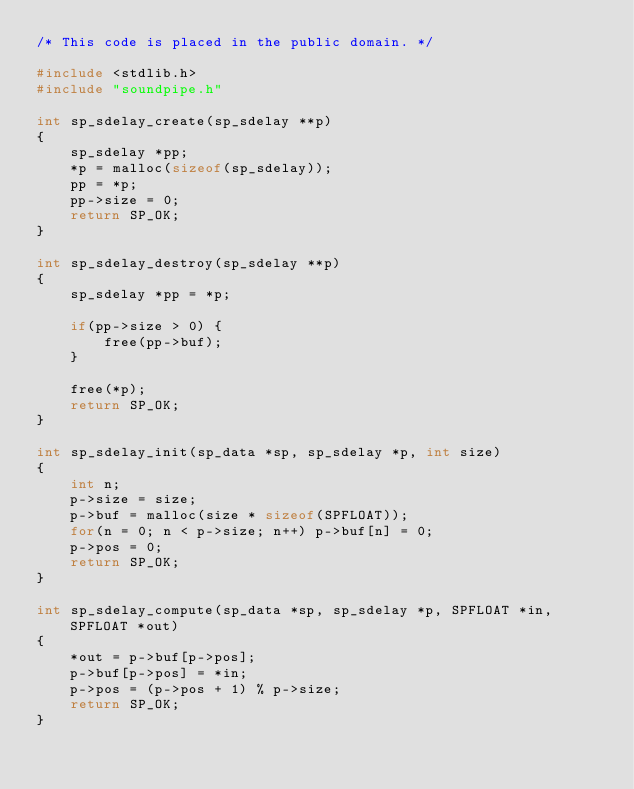<code> <loc_0><loc_0><loc_500><loc_500><_C_>/* This code is placed in the public domain. */

#include <stdlib.h>
#include "soundpipe.h"

int sp_sdelay_create(sp_sdelay **p)
{
    sp_sdelay *pp;
    *p = malloc(sizeof(sp_sdelay));
    pp = *p;
    pp->size = 0;
    return SP_OK;
}

int sp_sdelay_destroy(sp_sdelay **p)
{
    sp_sdelay *pp = *p;

    if(pp->size > 0) {
        free(pp->buf);
    }

    free(*p);
    return SP_OK;
}

int sp_sdelay_init(sp_data *sp, sp_sdelay *p, int size)
{
    int n;
    p->size = size;
    p->buf = malloc(size * sizeof(SPFLOAT));
    for(n = 0; n < p->size; n++) p->buf[n] = 0;
    p->pos = 0;
    return SP_OK;
}

int sp_sdelay_compute(sp_data *sp, sp_sdelay *p, SPFLOAT *in, SPFLOAT *out)
{
    *out = p->buf[p->pos];
    p->buf[p->pos] = *in;
    p->pos = (p->pos + 1) % p->size;
    return SP_OK;
}
</code> 